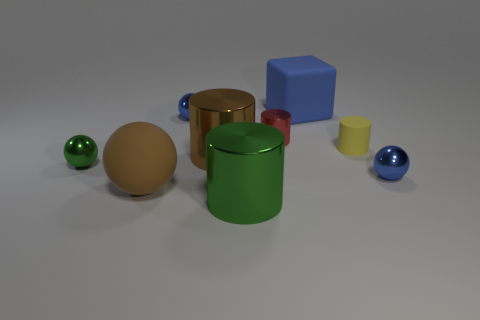There is a big rubber object behind the yellow cylinder that is in front of the large matte thing on the right side of the green shiny cylinder; what color is it?
Offer a terse response. Blue. How many objects are either tiny metallic things that are left of the large blue block or metallic cylinders that are behind the big green metal cylinder?
Your answer should be compact. 4. What number of other objects are the same color as the large matte sphere?
Keep it short and to the point. 1. Is the shape of the green metallic object in front of the big brown matte ball the same as  the big blue rubber object?
Make the answer very short. No. Is the number of brown objects in front of the brown cylinder less than the number of tiny rubber things?
Offer a terse response. No. Are there any tiny yellow cylinders made of the same material as the large green cylinder?
Provide a short and direct response. No. What material is the green cylinder that is the same size as the brown shiny thing?
Your answer should be compact. Metal. Is the number of green metallic things in front of the cube less than the number of objects that are to the right of the tiny green metal object?
Your answer should be compact. Yes. There is a object that is both in front of the yellow cylinder and on the right side of the blue matte block; what is its shape?
Offer a very short reply. Sphere. How many small blue objects have the same shape as the tiny green shiny object?
Make the answer very short. 2. 